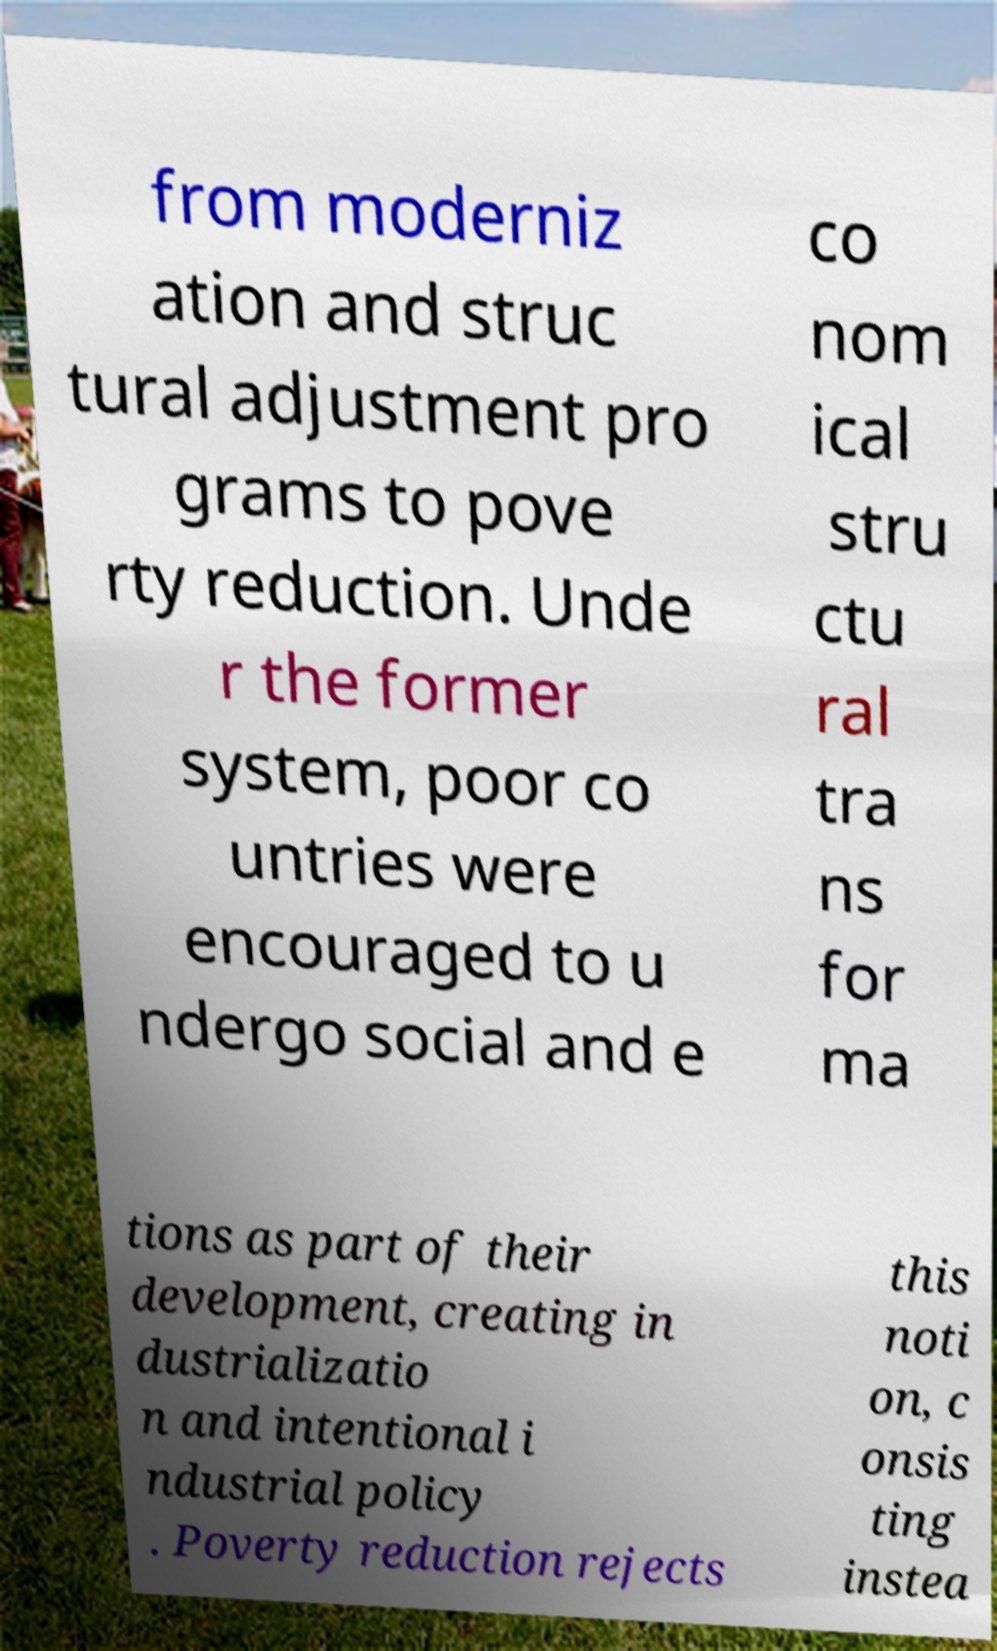What messages or text are displayed in this image? I need them in a readable, typed format. from moderniz ation and struc tural adjustment pro grams to pove rty reduction. Unde r the former system, poor co untries were encouraged to u ndergo social and e co nom ical stru ctu ral tra ns for ma tions as part of their development, creating in dustrializatio n and intentional i ndustrial policy . Poverty reduction rejects this noti on, c onsis ting instea 